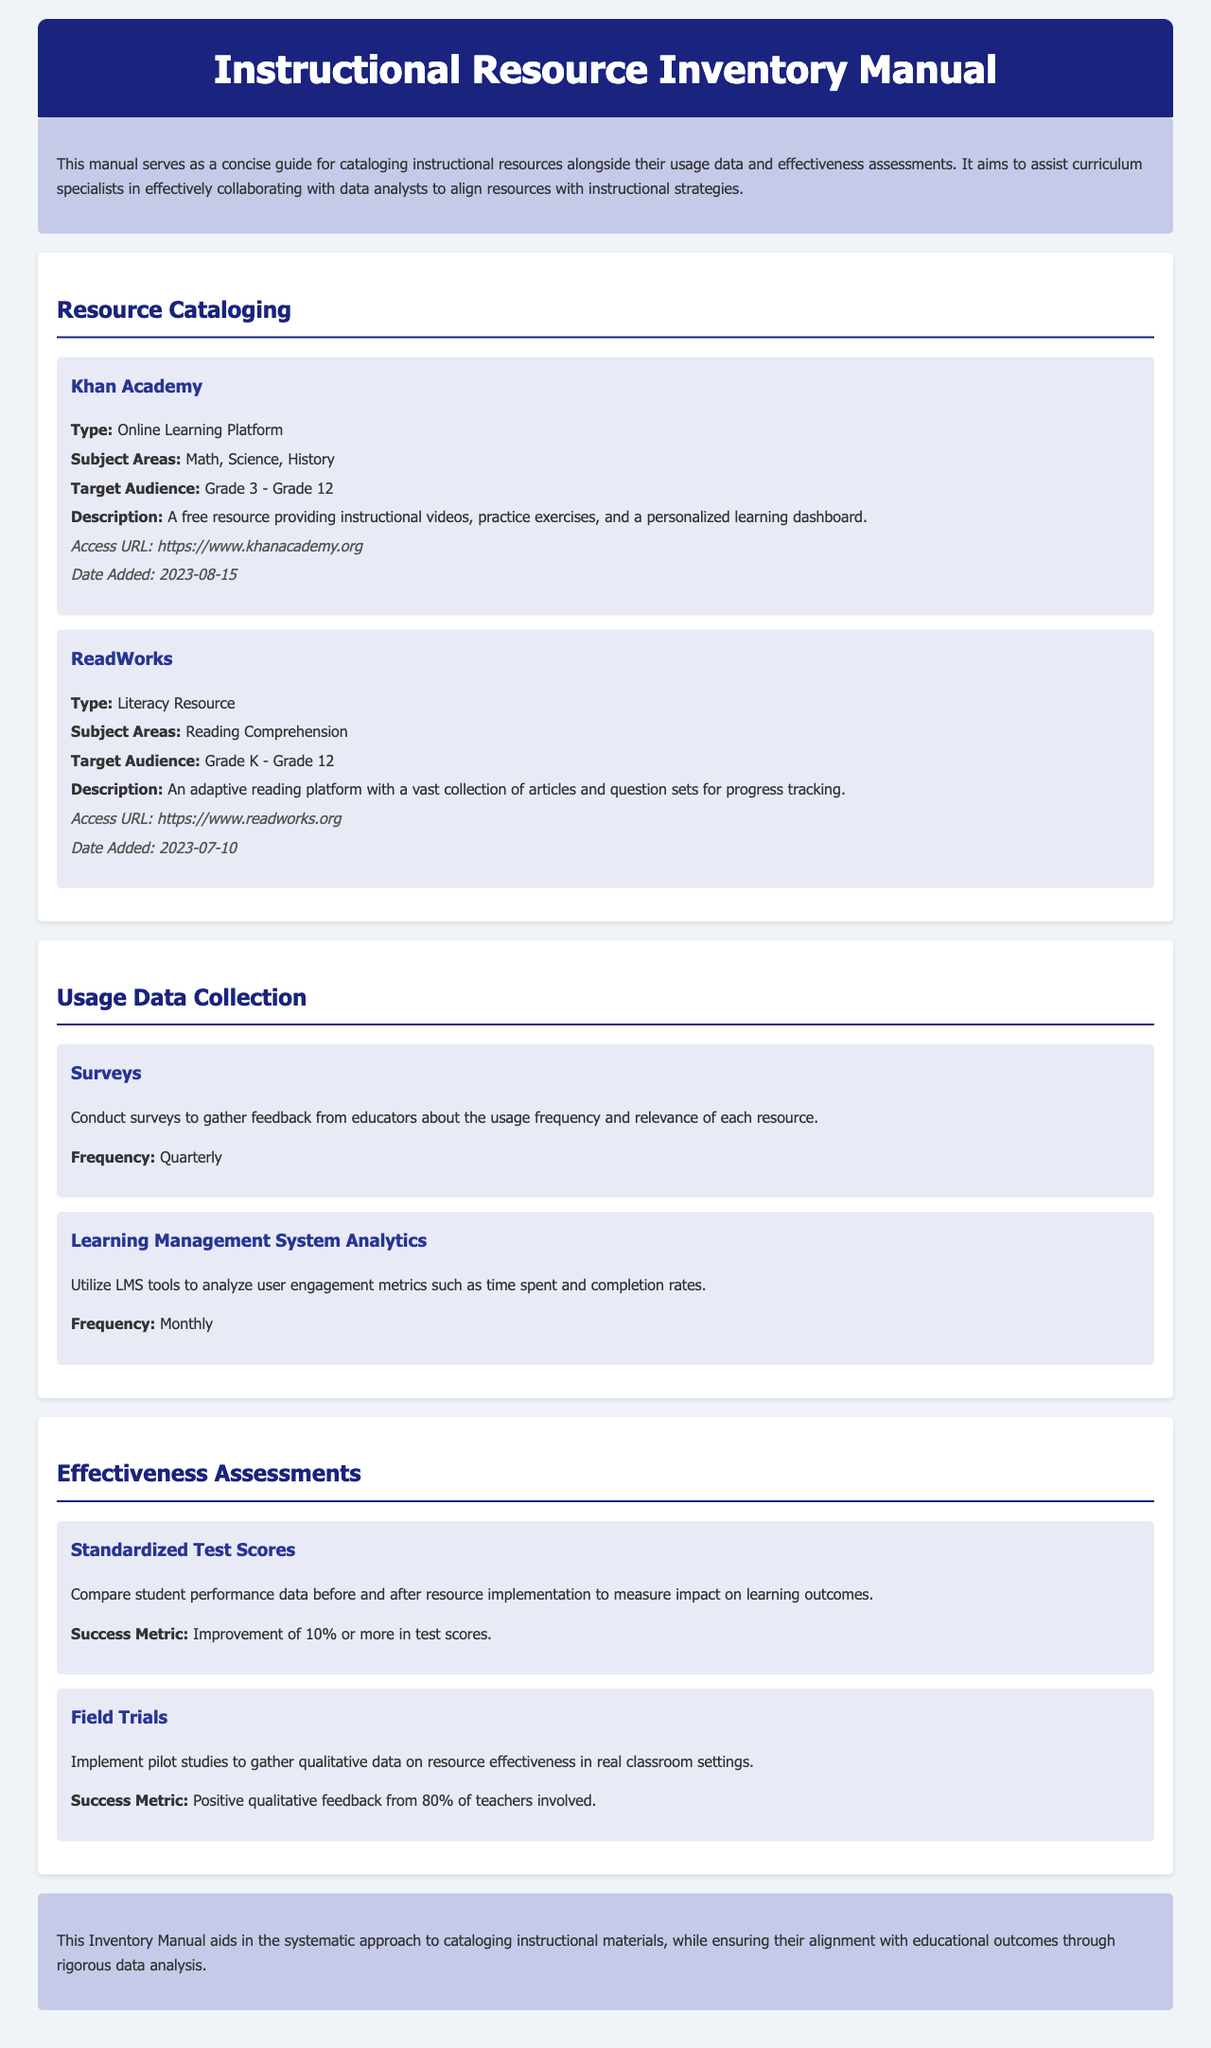What is the resource type of Khan Academy? The resource type of Khan Academy is specified in the document as "Online Learning Platform."
Answer: Online Learning Platform What subject areas does ReadWorks cover? The document lists "Reading Comprehension" as the subject area that ReadWorks covers.
Answer: Reading Comprehension When was Khan Academy added to the inventory? The document mentions that Khan Academy was added on "2023-08-15."
Answer: 2023-08-15 What is the frequency of surveys for usage data collection? The manual states that surveys should be conducted quarterly for usage data collection.
Answer: Quarterly What success metric is used for standardized test scores? The manual specifies that the success metric for standardized test scores is an "Improvement of 10% or more in test scores."
Answer: Improvement of 10% or more in test scores What is the target audience for ReadWorks? The document indicates that the target audience for ReadWorks is "Grade K - Grade 12."
Answer: Grade K - Grade 12 How many teachers' feedback is required for positive qualitative feedback in field trials? The document states that positive qualitative feedback from "80% of teachers involved" is required for field trials.
Answer: 80% of teachers involved What method is used to analyze user engagement metrics? The document describes "Learning Management System Analytics" as the method to analyze user engagement metrics.
Answer: Learning Management System Analytics 